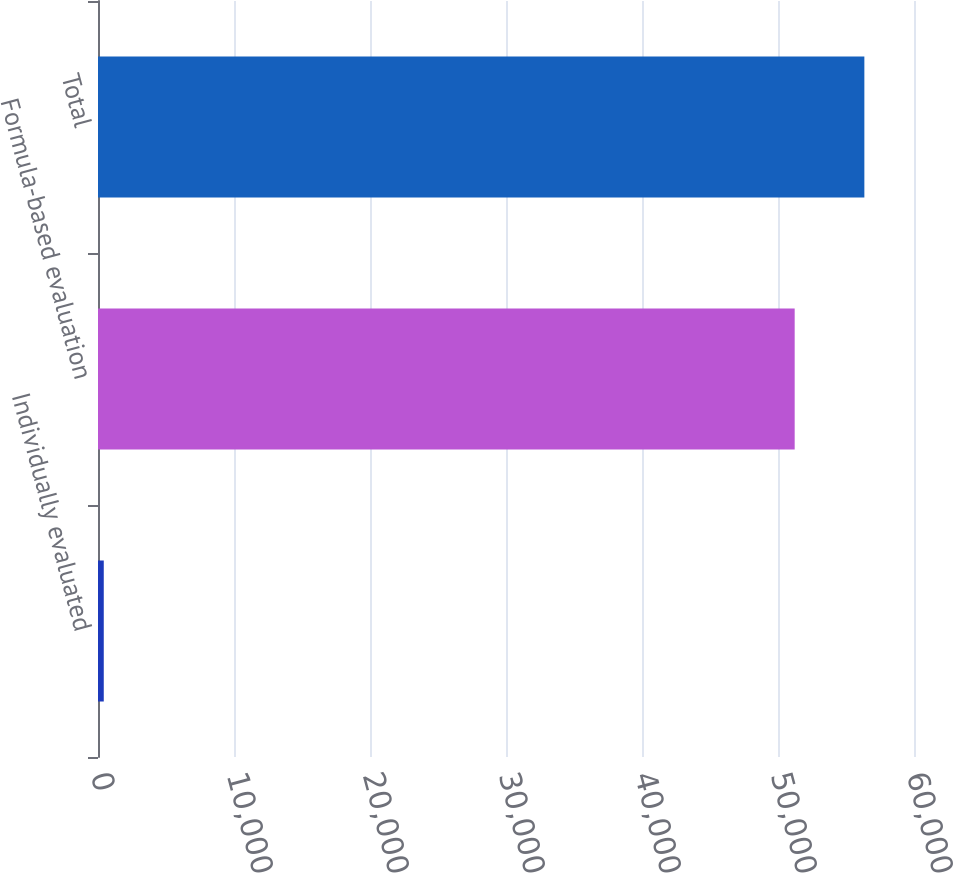Convert chart. <chart><loc_0><loc_0><loc_500><loc_500><bar_chart><fcel>Individually evaluated<fcel>Formula-based evaluation<fcel>Total<nl><fcel>424<fcel>51227<fcel>56349.7<nl></chart> 